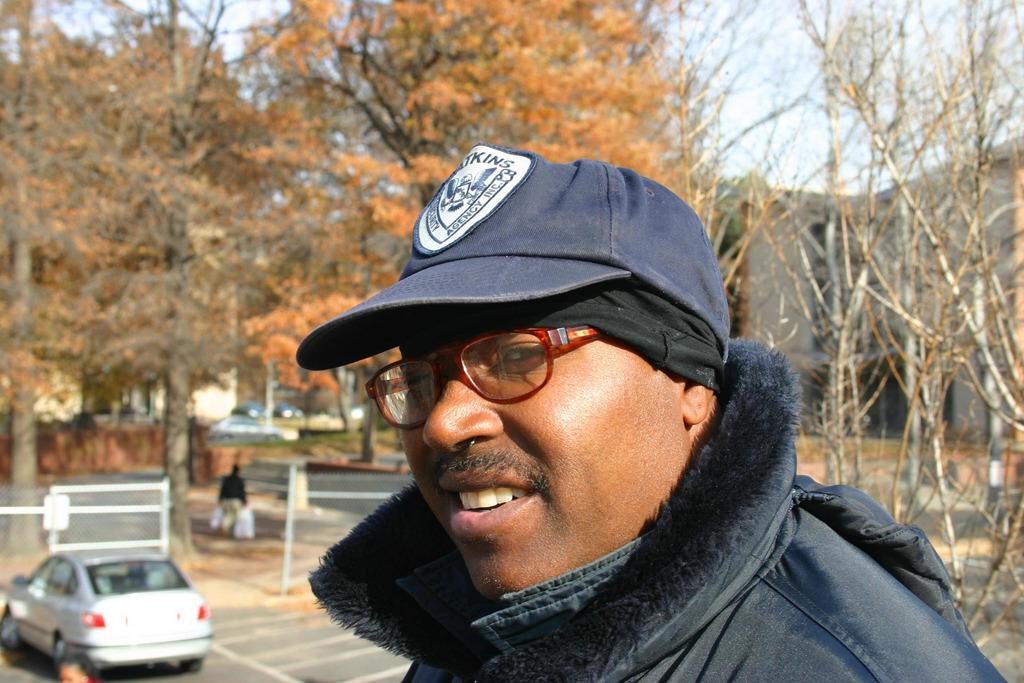How would you summarize this image in a sentence or two? Here in this picture we can see a person wearing a jacket and a cap and spectacles on him, smiling and behind him we can see a car present on the road and we can see trees present all over there and we can see railings present here and there and we can see other people also walking on the road and we can see buildings present here and there and we can also see other vehicles on the road. 